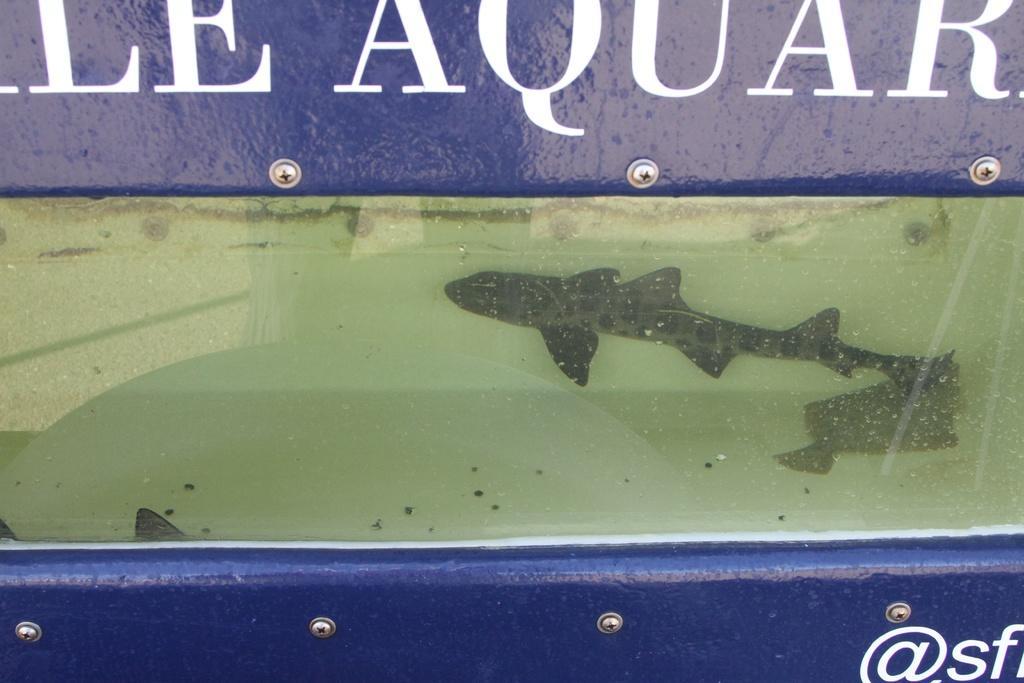Please provide a concise description of this image. In this image there are two fishes in the water, and there are boards with screws. 